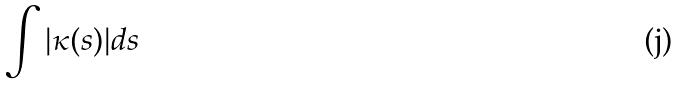<formula> <loc_0><loc_0><loc_500><loc_500>\int | \kappa ( s ) | d s</formula> 